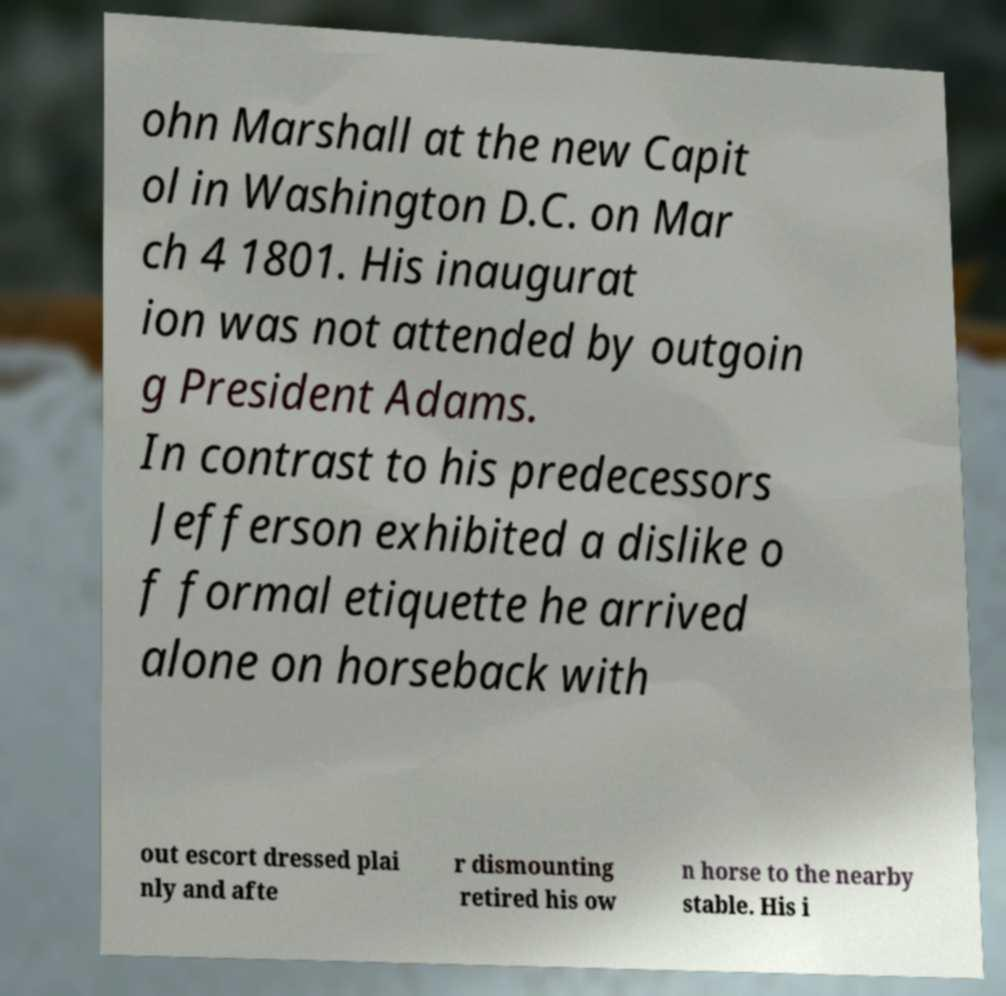I need the written content from this picture converted into text. Can you do that? ohn Marshall at the new Capit ol in Washington D.C. on Mar ch 4 1801. His inaugurat ion was not attended by outgoin g President Adams. In contrast to his predecessors Jefferson exhibited a dislike o f formal etiquette he arrived alone on horseback with out escort dressed plai nly and afte r dismounting retired his ow n horse to the nearby stable. His i 